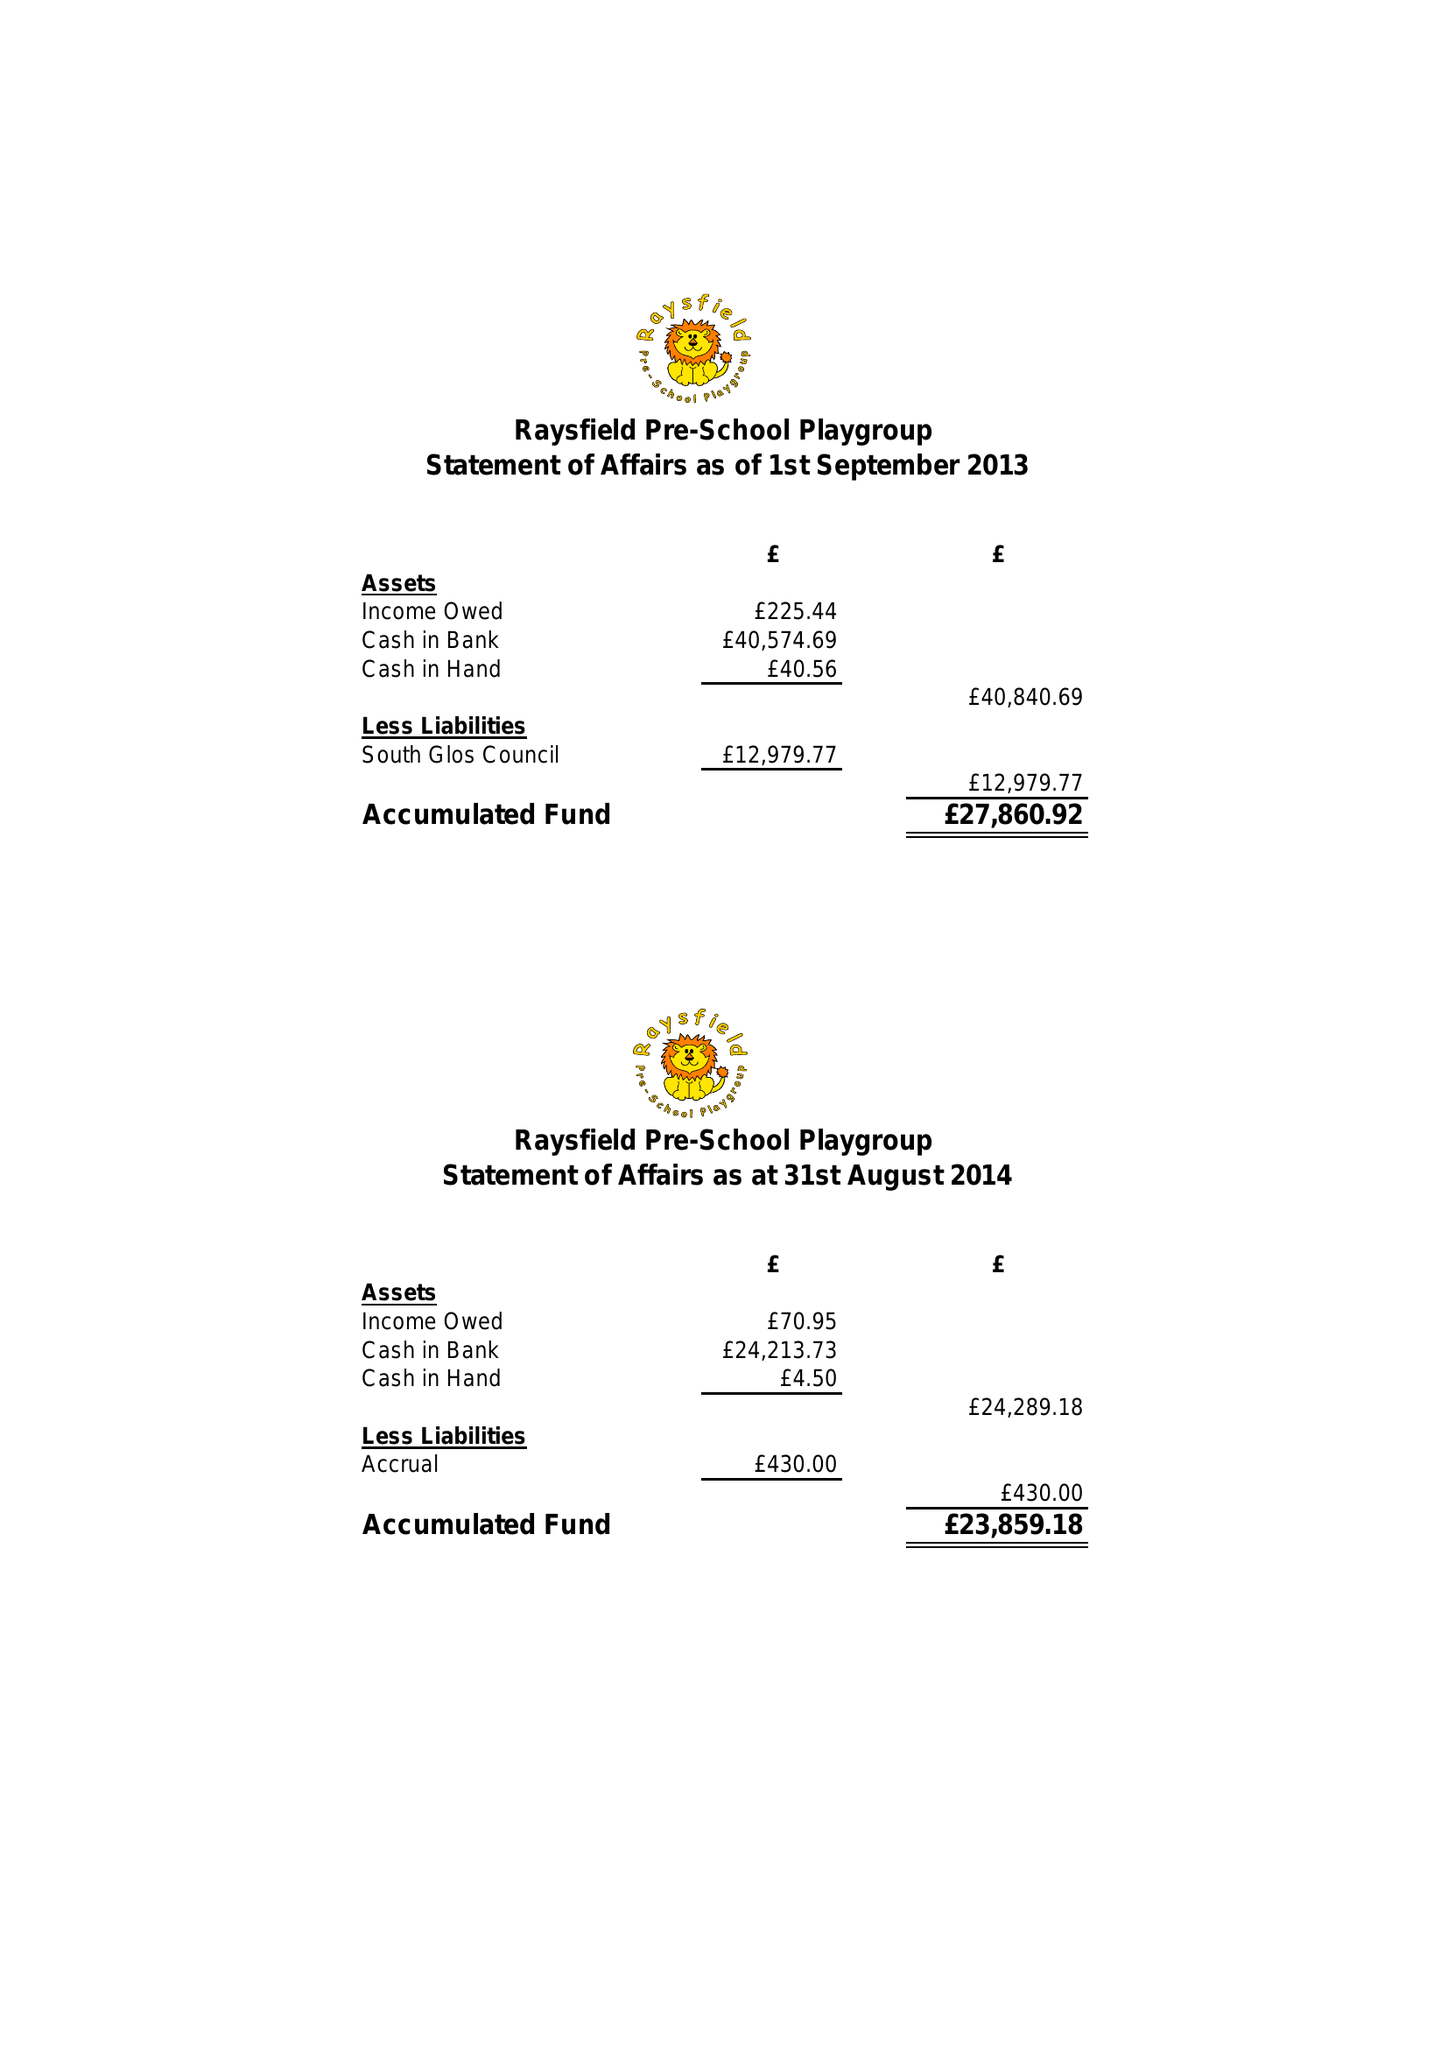What is the value for the income_annually_in_british_pounds?
Answer the question using a single word or phrase. 79761.36 